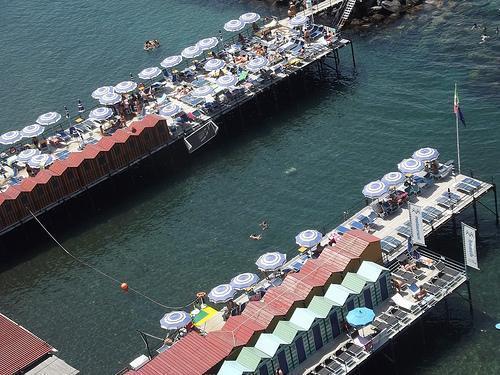How many blue umbrellas are in the image?
Give a very brief answer. 1. 